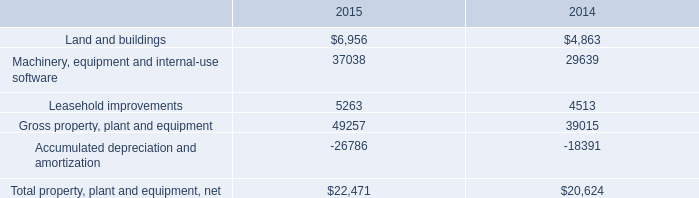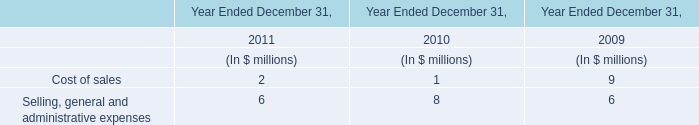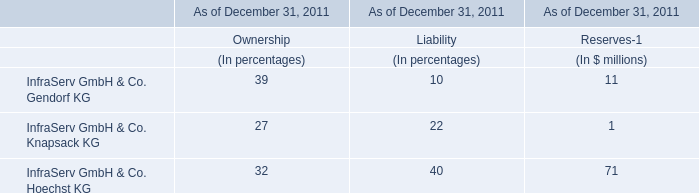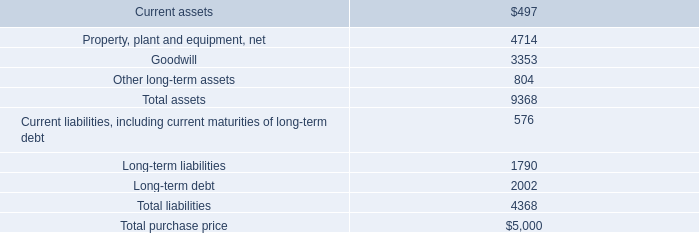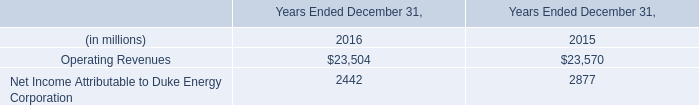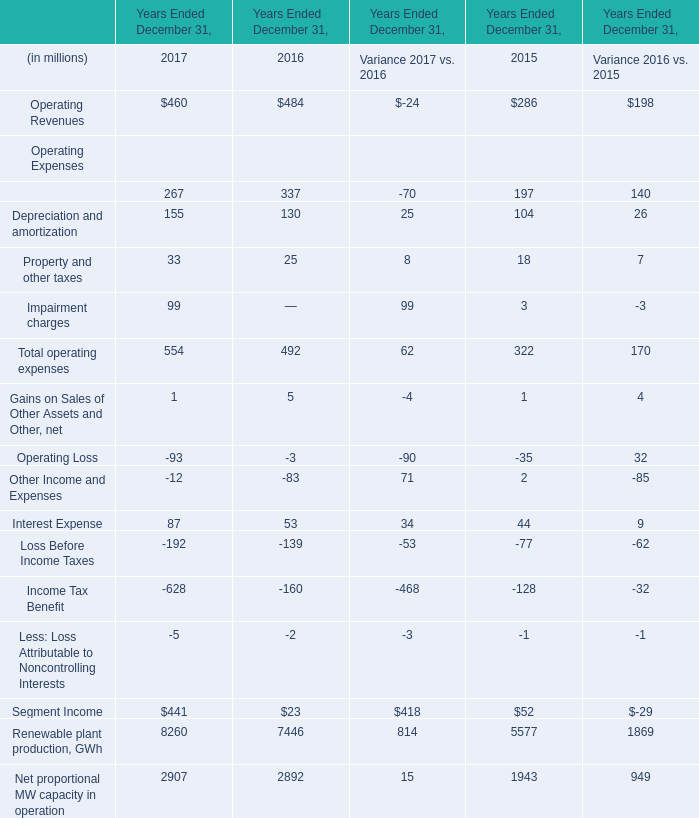In the year with largest amount of depreciation and amortization, what's the sum of Operating Expenses? (in million) 
Computations: (((267 + 155) + 33) + 99)
Answer: 554.0. 